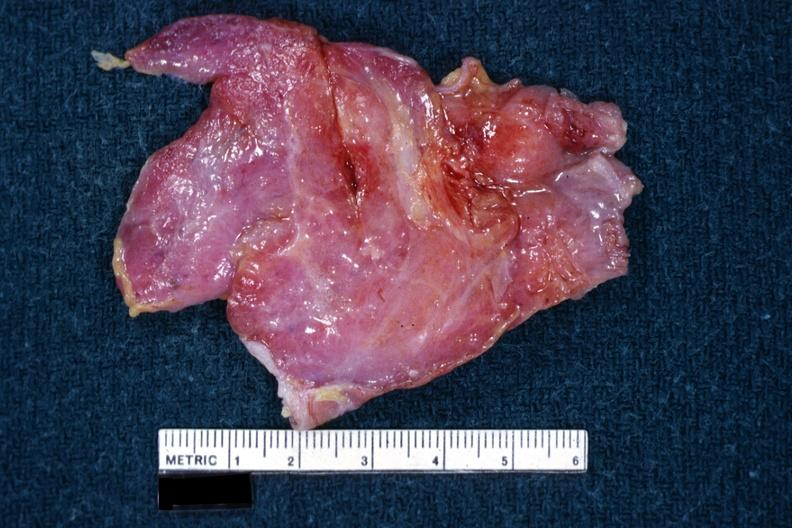s female reproductive a thymus?
Answer the question using a single word or phrase. No 